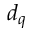<formula> <loc_0><loc_0><loc_500><loc_500>d _ { q }</formula> 